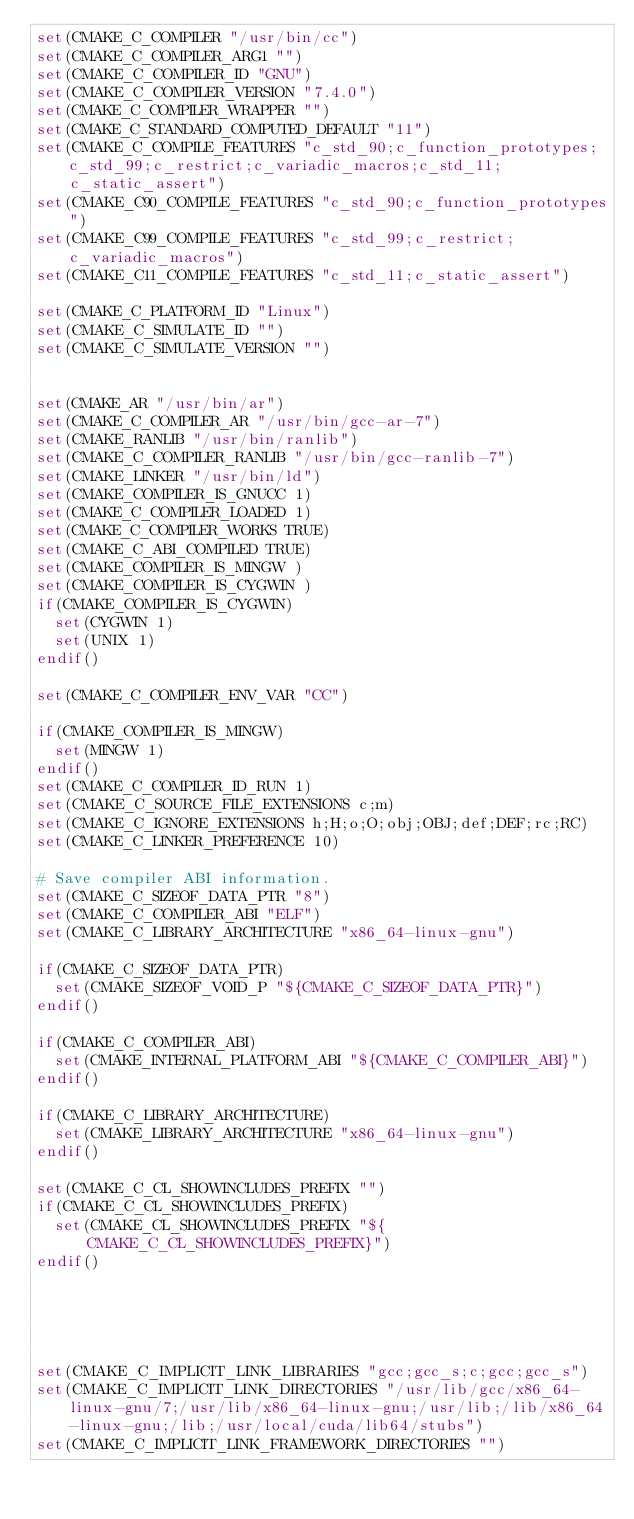<code> <loc_0><loc_0><loc_500><loc_500><_CMake_>set(CMAKE_C_COMPILER "/usr/bin/cc")
set(CMAKE_C_COMPILER_ARG1 "")
set(CMAKE_C_COMPILER_ID "GNU")
set(CMAKE_C_COMPILER_VERSION "7.4.0")
set(CMAKE_C_COMPILER_WRAPPER "")
set(CMAKE_C_STANDARD_COMPUTED_DEFAULT "11")
set(CMAKE_C_COMPILE_FEATURES "c_std_90;c_function_prototypes;c_std_99;c_restrict;c_variadic_macros;c_std_11;c_static_assert")
set(CMAKE_C90_COMPILE_FEATURES "c_std_90;c_function_prototypes")
set(CMAKE_C99_COMPILE_FEATURES "c_std_99;c_restrict;c_variadic_macros")
set(CMAKE_C11_COMPILE_FEATURES "c_std_11;c_static_assert")

set(CMAKE_C_PLATFORM_ID "Linux")
set(CMAKE_C_SIMULATE_ID "")
set(CMAKE_C_SIMULATE_VERSION "")


set(CMAKE_AR "/usr/bin/ar")
set(CMAKE_C_COMPILER_AR "/usr/bin/gcc-ar-7")
set(CMAKE_RANLIB "/usr/bin/ranlib")
set(CMAKE_C_COMPILER_RANLIB "/usr/bin/gcc-ranlib-7")
set(CMAKE_LINKER "/usr/bin/ld")
set(CMAKE_COMPILER_IS_GNUCC 1)
set(CMAKE_C_COMPILER_LOADED 1)
set(CMAKE_C_COMPILER_WORKS TRUE)
set(CMAKE_C_ABI_COMPILED TRUE)
set(CMAKE_COMPILER_IS_MINGW )
set(CMAKE_COMPILER_IS_CYGWIN )
if(CMAKE_COMPILER_IS_CYGWIN)
  set(CYGWIN 1)
  set(UNIX 1)
endif()

set(CMAKE_C_COMPILER_ENV_VAR "CC")

if(CMAKE_COMPILER_IS_MINGW)
  set(MINGW 1)
endif()
set(CMAKE_C_COMPILER_ID_RUN 1)
set(CMAKE_C_SOURCE_FILE_EXTENSIONS c;m)
set(CMAKE_C_IGNORE_EXTENSIONS h;H;o;O;obj;OBJ;def;DEF;rc;RC)
set(CMAKE_C_LINKER_PREFERENCE 10)

# Save compiler ABI information.
set(CMAKE_C_SIZEOF_DATA_PTR "8")
set(CMAKE_C_COMPILER_ABI "ELF")
set(CMAKE_C_LIBRARY_ARCHITECTURE "x86_64-linux-gnu")

if(CMAKE_C_SIZEOF_DATA_PTR)
  set(CMAKE_SIZEOF_VOID_P "${CMAKE_C_SIZEOF_DATA_PTR}")
endif()

if(CMAKE_C_COMPILER_ABI)
  set(CMAKE_INTERNAL_PLATFORM_ABI "${CMAKE_C_COMPILER_ABI}")
endif()

if(CMAKE_C_LIBRARY_ARCHITECTURE)
  set(CMAKE_LIBRARY_ARCHITECTURE "x86_64-linux-gnu")
endif()

set(CMAKE_C_CL_SHOWINCLUDES_PREFIX "")
if(CMAKE_C_CL_SHOWINCLUDES_PREFIX)
  set(CMAKE_CL_SHOWINCLUDES_PREFIX "${CMAKE_C_CL_SHOWINCLUDES_PREFIX}")
endif()





set(CMAKE_C_IMPLICIT_LINK_LIBRARIES "gcc;gcc_s;c;gcc;gcc_s")
set(CMAKE_C_IMPLICIT_LINK_DIRECTORIES "/usr/lib/gcc/x86_64-linux-gnu/7;/usr/lib/x86_64-linux-gnu;/usr/lib;/lib/x86_64-linux-gnu;/lib;/usr/local/cuda/lib64/stubs")
set(CMAKE_C_IMPLICIT_LINK_FRAMEWORK_DIRECTORIES "")
</code> 